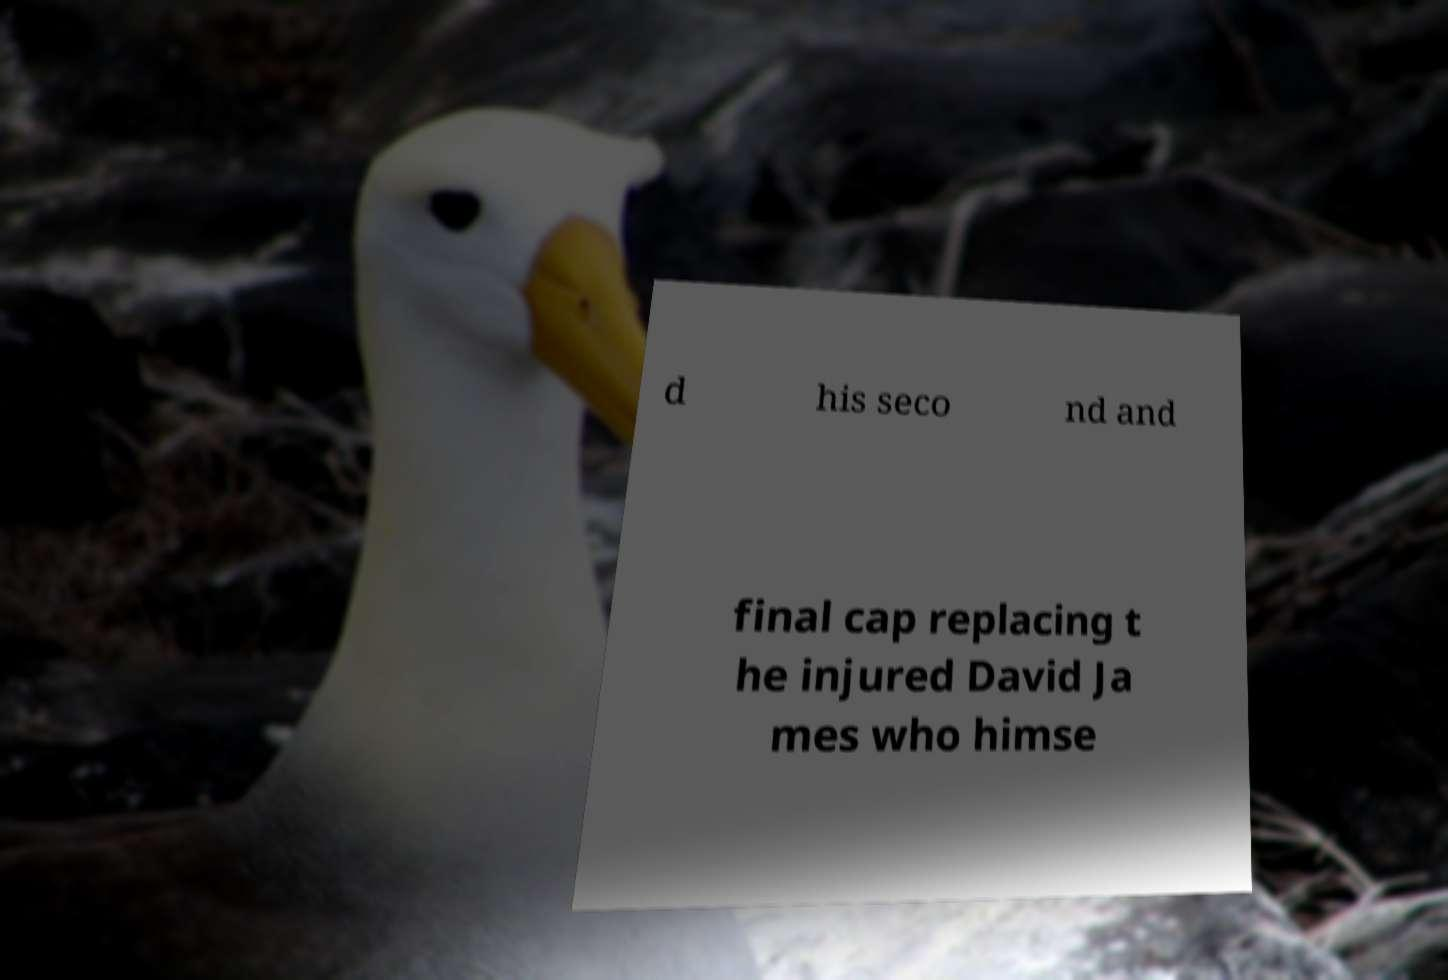There's text embedded in this image that I need extracted. Can you transcribe it verbatim? d his seco nd and final cap replacing t he injured David Ja mes who himse 